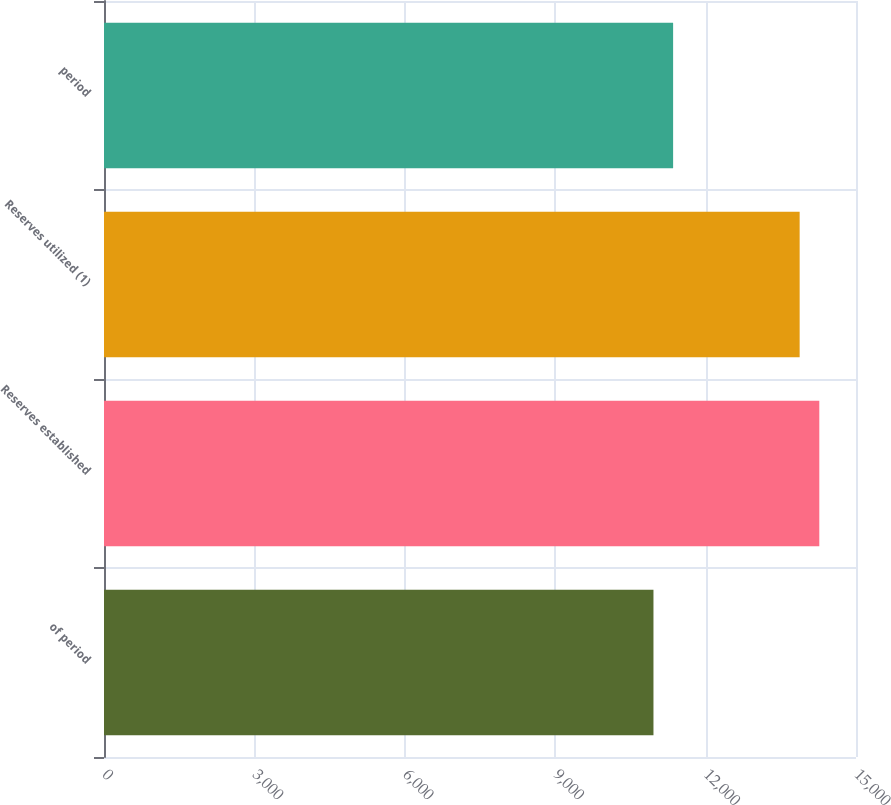Convert chart. <chart><loc_0><loc_0><loc_500><loc_500><bar_chart><fcel>of period<fcel>Reserves established<fcel>Reserves utilized (1)<fcel>period<nl><fcel>10960<fcel>14268<fcel>13876<fcel>11352<nl></chart> 